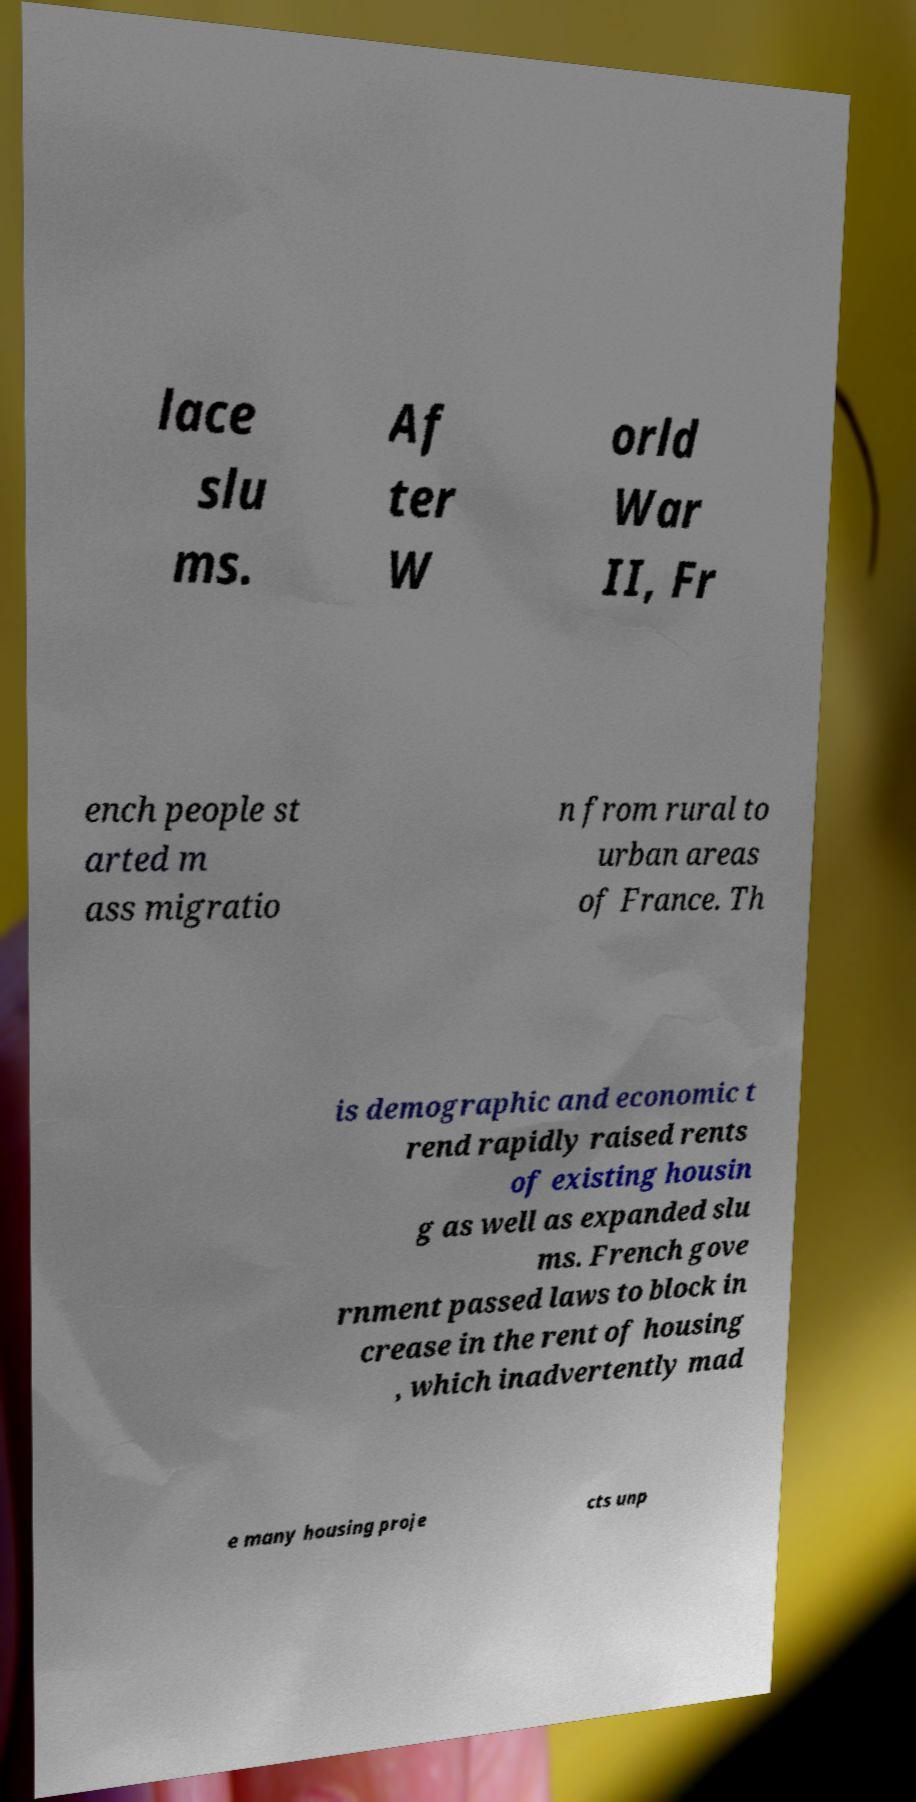Could you extract and type out the text from this image? lace slu ms. Af ter W orld War II, Fr ench people st arted m ass migratio n from rural to urban areas of France. Th is demographic and economic t rend rapidly raised rents of existing housin g as well as expanded slu ms. French gove rnment passed laws to block in crease in the rent of housing , which inadvertently mad e many housing proje cts unp 